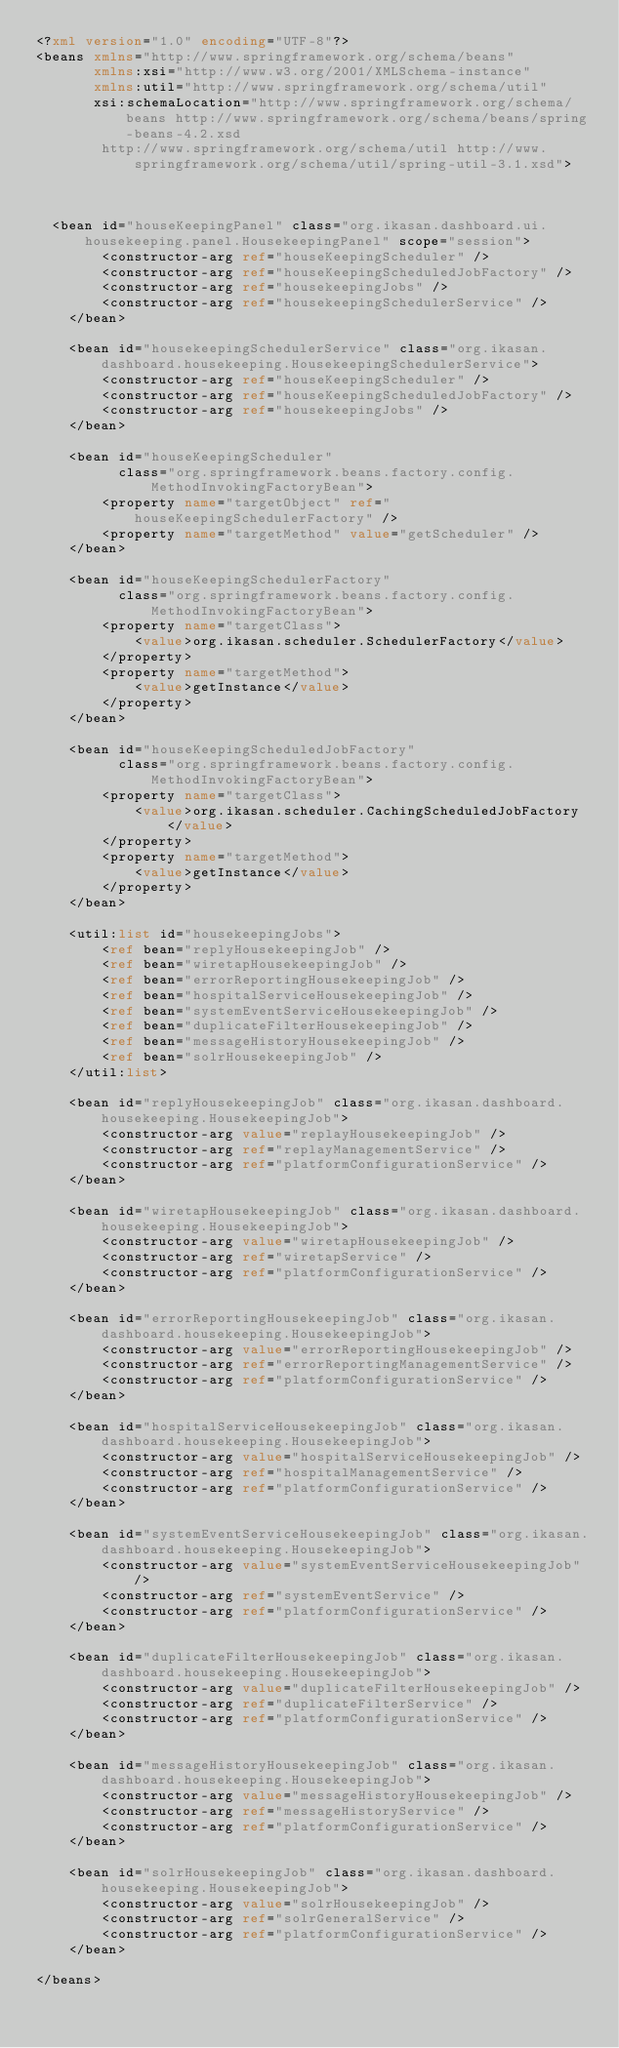Convert code to text. <code><loc_0><loc_0><loc_500><loc_500><_XML_><?xml version="1.0" encoding="UTF-8"?>
<beans xmlns="http://www.springframework.org/schema/beans"
       xmlns:xsi="http://www.w3.org/2001/XMLSchema-instance"
       xmlns:util="http://www.springframework.org/schema/util"
       xsi:schemaLocation="http://www.springframework.org/schema/beans http://www.springframework.org/schema/beans/spring-beans-4.2.xsd
        http://www.springframework.org/schema/util http://www.springframework.org/schema/util/spring-util-3.1.xsd">



	<bean id="houseKeepingPanel" class="org.ikasan.dashboard.ui.housekeeping.panel.HousekeepingPanel" scope="session">
        <constructor-arg ref="houseKeepingScheduler" />
        <constructor-arg ref="houseKeepingScheduledJobFactory" />
        <constructor-arg ref="housekeepingJobs" />
        <constructor-arg ref="housekeepingSchedulerService" />
    </bean>

    <bean id="housekeepingSchedulerService" class="org.ikasan.dashboard.housekeeping.HousekeepingSchedulerService">
        <constructor-arg ref="houseKeepingScheduler" />
        <constructor-arg ref="houseKeepingScheduledJobFactory" />
        <constructor-arg ref="housekeepingJobs" />
    </bean>

    <bean id="houseKeepingScheduler"
          class="org.springframework.beans.factory.config.MethodInvokingFactoryBean">
        <property name="targetObject" ref="houseKeepingSchedulerFactory" />
        <property name="targetMethod" value="getScheduler" />
    </bean>

    <bean id="houseKeepingSchedulerFactory"
          class="org.springframework.beans.factory.config.MethodInvokingFactoryBean">
        <property name="targetClass">
            <value>org.ikasan.scheduler.SchedulerFactory</value>
        </property>
        <property name="targetMethod">
            <value>getInstance</value>
        </property>
    </bean>

    <bean id="houseKeepingScheduledJobFactory"
          class="org.springframework.beans.factory.config.MethodInvokingFactoryBean">
        <property name="targetClass">
            <value>org.ikasan.scheduler.CachingScheduledJobFactory</value>
        </property>
        <property name="targetMethod">
            <value>getInstance</value>
        </property>
    </bean>

    <util:list id="housekeepingJobs">
        <ref bean="replyHousekeepingJob" />
        <ref bean="wiretapHousekeepingJob" />
        <ref bean="errorReportingHousekeepingJob" />
        <ref bean="hospitalServiceHousekeepingJob" />
        <ref bean="systemEventServiceHousekeepingJob" />
        <ref bean="duplicateFilterHousekeepingJob" />
        <ref bean="messageHistoryHousekeepingJob" />
        <ref bean="solrHousekeepingJob" />
    </util:list>

    <bean id="replyHousekeepingJob" class="org.ikasan.dashboard.housekeeping.HousekeepingJob">
        <constructor-arg value="replayHousekeepingJob" />
        <constructor-arg ref="replayManagementService" />
        <constructor-arg ref="platformConfigurationService" />
    </bean>

    <bean id="wiretapHousekeepingJob" class="org.ikasan.dashboard.housekeeping.HousekeepingJob">
        <constructor-arg value="wiretapHousekeepingJob" />
        <constructor-arg ref="wiretapService" />
        <constructor-arg ref="platformConfigurationService" />
    </bean>

    <bean id="errorReportingHousekeepingJob" class="org.ikasan.dashboard.housekeeping.HousekeepingJob">
        <constructor-arg value="errorReportingHousekeepingJob" />
        <constructor-arg ref="errorReportingManagementService" />
        <constructor-arg ref="platformConfigurationService" />
    </bean>

    <bean id="hospitalServiceHousekeepingJob" class="org.ikasan.dashboard.housekeeping.HousekeepingJob">
        <constructor-arg value="hospitalServiceHousekeepingJob" />
        <constructor-arg ref="hospitalManagementService" />
        <constructor-arg ref="platformConfigurationService" />
    </bean>

    <bean id="systemEventServiceHousekeepingJob" class="org.ikasan.dashboard.housekeeping.HousekeepingJob">
        <constructor-arg value="systemEventServiceHousekeepingJob" />
        <constructor-arg ref="systemEventService" />
        <constructor-arg ref="platformConfigurationService" />
    </bean>

    <bean id="duplicateFilterHousekeepingJob" class="org.ikasan.dashboard.housekeeping.HousekeepingJob">
        <constructor-arg value="duplicateFilterHousekeepingJob" />
        <constructor-arg ref="duplicateFilterService" />
        <constructor-arg ref="platformConfigurationService" />
    </bean>

    <bean id="messageHistoryHousekeepingJob" class="org.ikasan.dashboard.housekeeping.HousekeepingJob">
        <constructor-arg value="messageHistoryHousekeepingJob" />
        <constructor-arg ref="messageHistoryService" />
        <constructor-arg ref="platformConfigurationService" />
    </bean>

    <bean id="solrHousekeepingJob" class="org.ikasan.dashboard.housekeeping.HousekeepingJob">
        <constructor-arg value="solrHousekeepingJob" />
        <constructor-arg ref="solrGeneralService" />
        <constructor-arg ref="platformConfigurationService" />
    </bean>

</beans></code> 